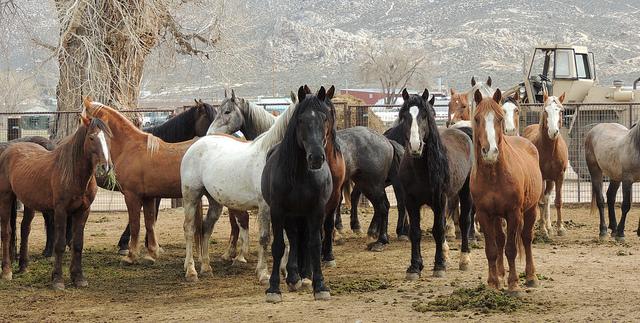What is behind the horses?
Short answer required. Tractor. Are the horses clean?
Short answer required. No. How many horses are there total?
Keep it brief. 14. 